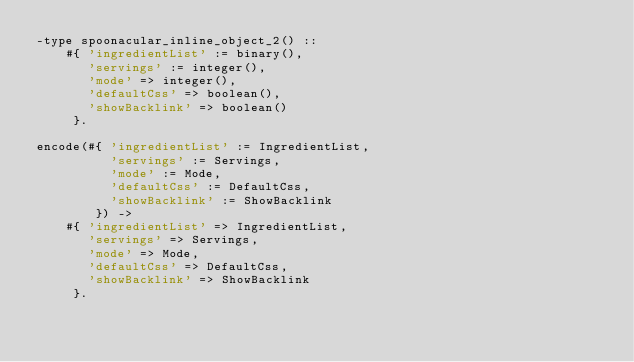<code> <loc_0><loc_0><loc_500><loc_500><_Erlang_>-type spoonacular_inline_object_2() ::
    #{ 'ingredientList' := binary(),
       'servings' := integer(),
       'mode' => integer(),
       'defaultCss' => boolean(),
       'showBacklink' => boolean()
     }.

encode(#{ 'ingredientList' := IngredientList,
          'servings' := Servings,
          'mode' := Mode,
          'defaultCss' := DefaultCss,
          'showBacklink' := ShowBacklink
        }) ->
    #{ 'ingredientList' => IngredientList,
       'servings' => Servings,
       'mode' => Mode,
       'defaultCss' => DefaultCss,
       'showBacklink' => ShowBacklink
     }.
</code> 